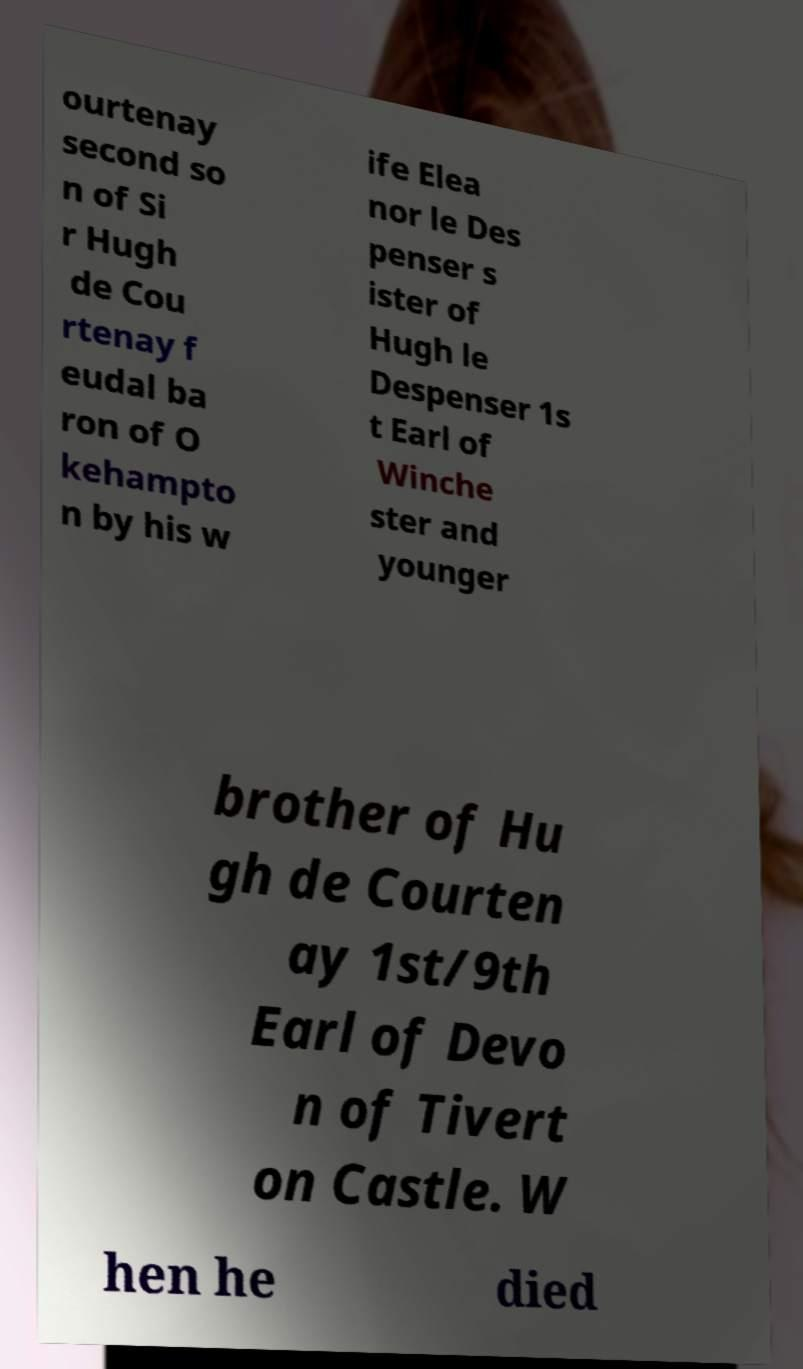Can you accurately transcribe the text from the provided image for me? ourtenay second so n of Si r Hugh de Cou rtenay f eudal ba ron of O kehampto n by his w ife Elea nor le Des penser s ister of Hugh le Despenser 1s t Earl of Winche ster and younger brother of Hu gh de Courten ay 1st/9th Earl of Devo n of Tivert on Castle. W hen he died 